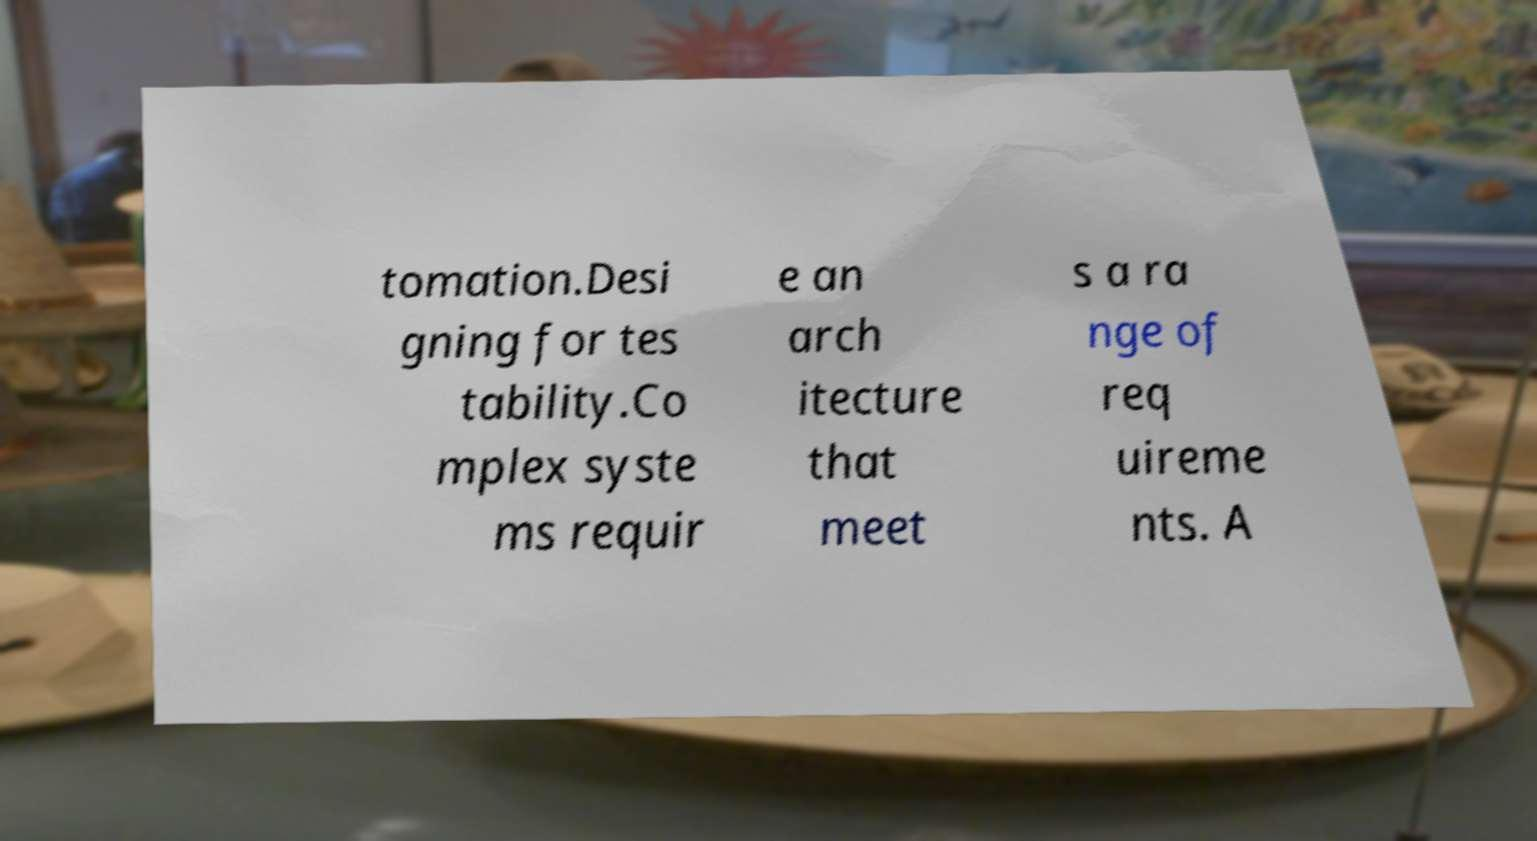For documentation purposes, I need the text within this image transcribed. Could you provide that? tomation.Desi gning for tes tability.Co mplex syste ms requir e an arch itecture that meet s a ra nge of req uireme nts. A 